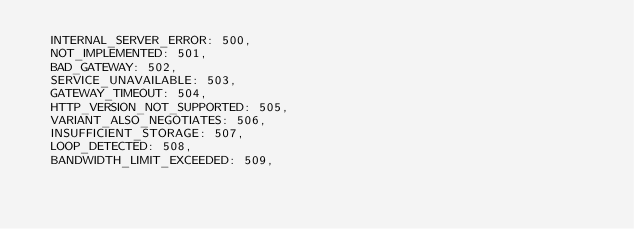Convert code to text. <code><loc_0><loc_0><loc_500><loc_500><_TypeScript_>  INTERNAL_SERVER_ERROR: 500,
  NOT_IMPLEMENTED: 501,
  BAD_GATEWAY: 502,
  SERVICE_UNAVAILABLE: 503,
  GATEWAY_TIMEOUT: 504,
  HTTP_VERSION_NOT_SUPPORTED: 505,
  VARIANT_ALSO_NEGOTIATES: 506,
  INSUFFICIENT_STORAGE: 507,
  LOOP_DETECTED: 508,
  BANDWIDTH_LIMIT_EXCEEDED: 509,</code> 